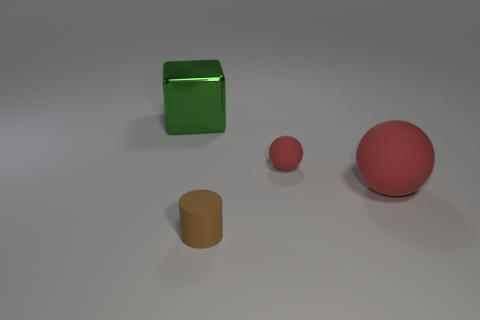Add 2 big purple objects. How many objects exist? 6 Subtract all brown spheres. Subtract all cyan cubes. How many spheres are left? 2 Subtract all cylinders. How many objects are left? 3 Add 4 large red rubber spheres. How many large red rubber spheres are left? 5 Add 1 small shiny things. How many small shiny things exist? 1 Subtract 0 red blocks. How many objects are left? 4 Subtract all brown rubber cylinders. Subtract all large spheres. How many objects are left? 2 